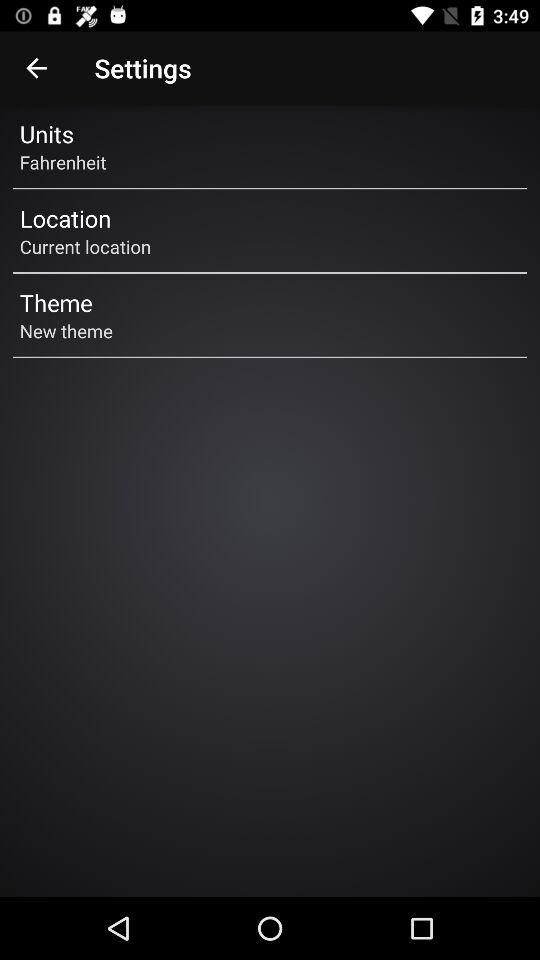What's the "Location" setting? The "Location" setting is set to the current location. 